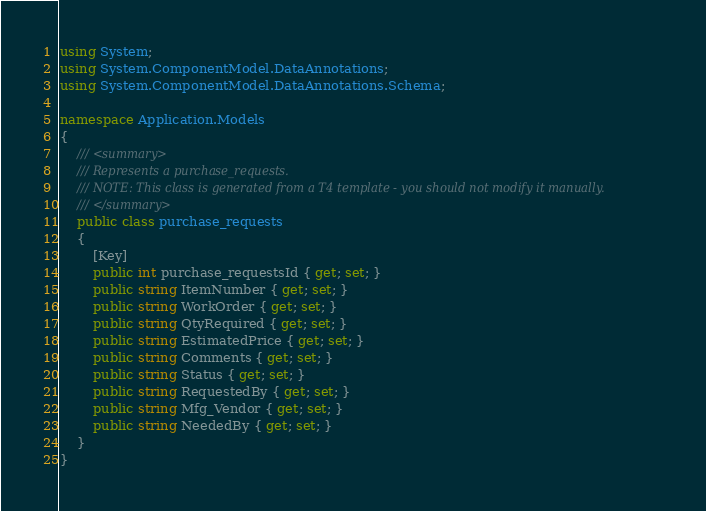<code> <loc_0><loc_0><loc_500><loc_500><_C#_>using System;
using System.ComponentModel.DataAnnotations;
using System.ComponentModel.DataAnnotations.Schema;

namespace Application.Models
{
    /// <summary>
    /// Represents a purchase_requests.
    /// NOTE: This class is generated from a T4 template - you should not modify it manually.
    /// </summary>
    public class purchase_requests 
    {	
		[Key]
        public int purchase_requestsId { get; set; }
        public string ItemNumber { get; set; }
        public string WorkOrder { get; set; }
        public string QtyRequired { get; set; }
        public string EstimatedPrice { get; set; }
        public string Comments { get; set; }
        public string Status { get; set; }
        public string RequestedBy { get; set; }
        public string Mfg_Vendor { get; set; }
        public string NeededBy { get; set; }
    }
}      
</code> 